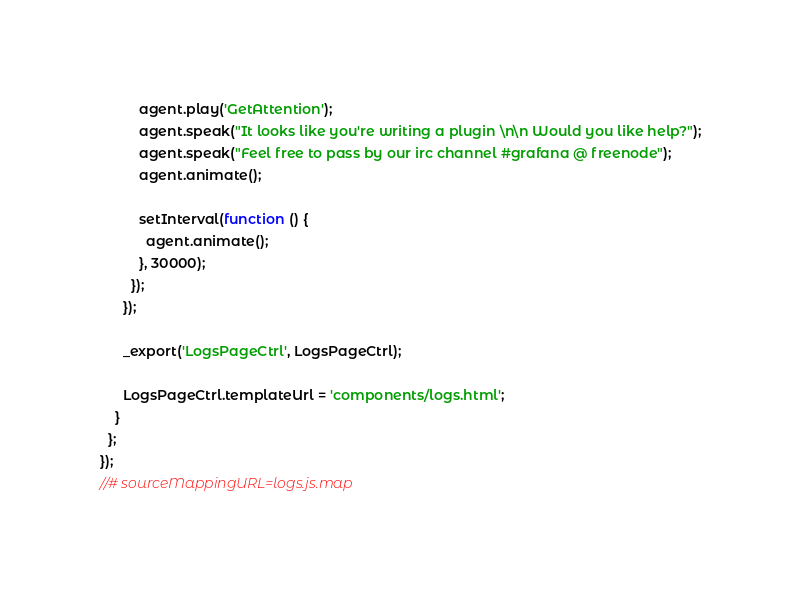<code> <loc_0><loc_0><loc_500><loc_500><_JavaScript_>          agent.play('GetAttention');
          agent.speak("It looks like you're writing a plugin \n\n Would you like help?");
          agent.speak("Feel free to pass by our irc channel #grafana @ freenode");
          agent.animate();

          setInterval(function () {
            agent.animate();
          }, 30000);
        });
      });

      _export('LogsPageCtrl', LogsPageCtrl);

      LogsPageCtrl.templateUrl = 'components/logs.html';
    }
  };
});
//# sourceMappingURL=logs.js.map
</code> 